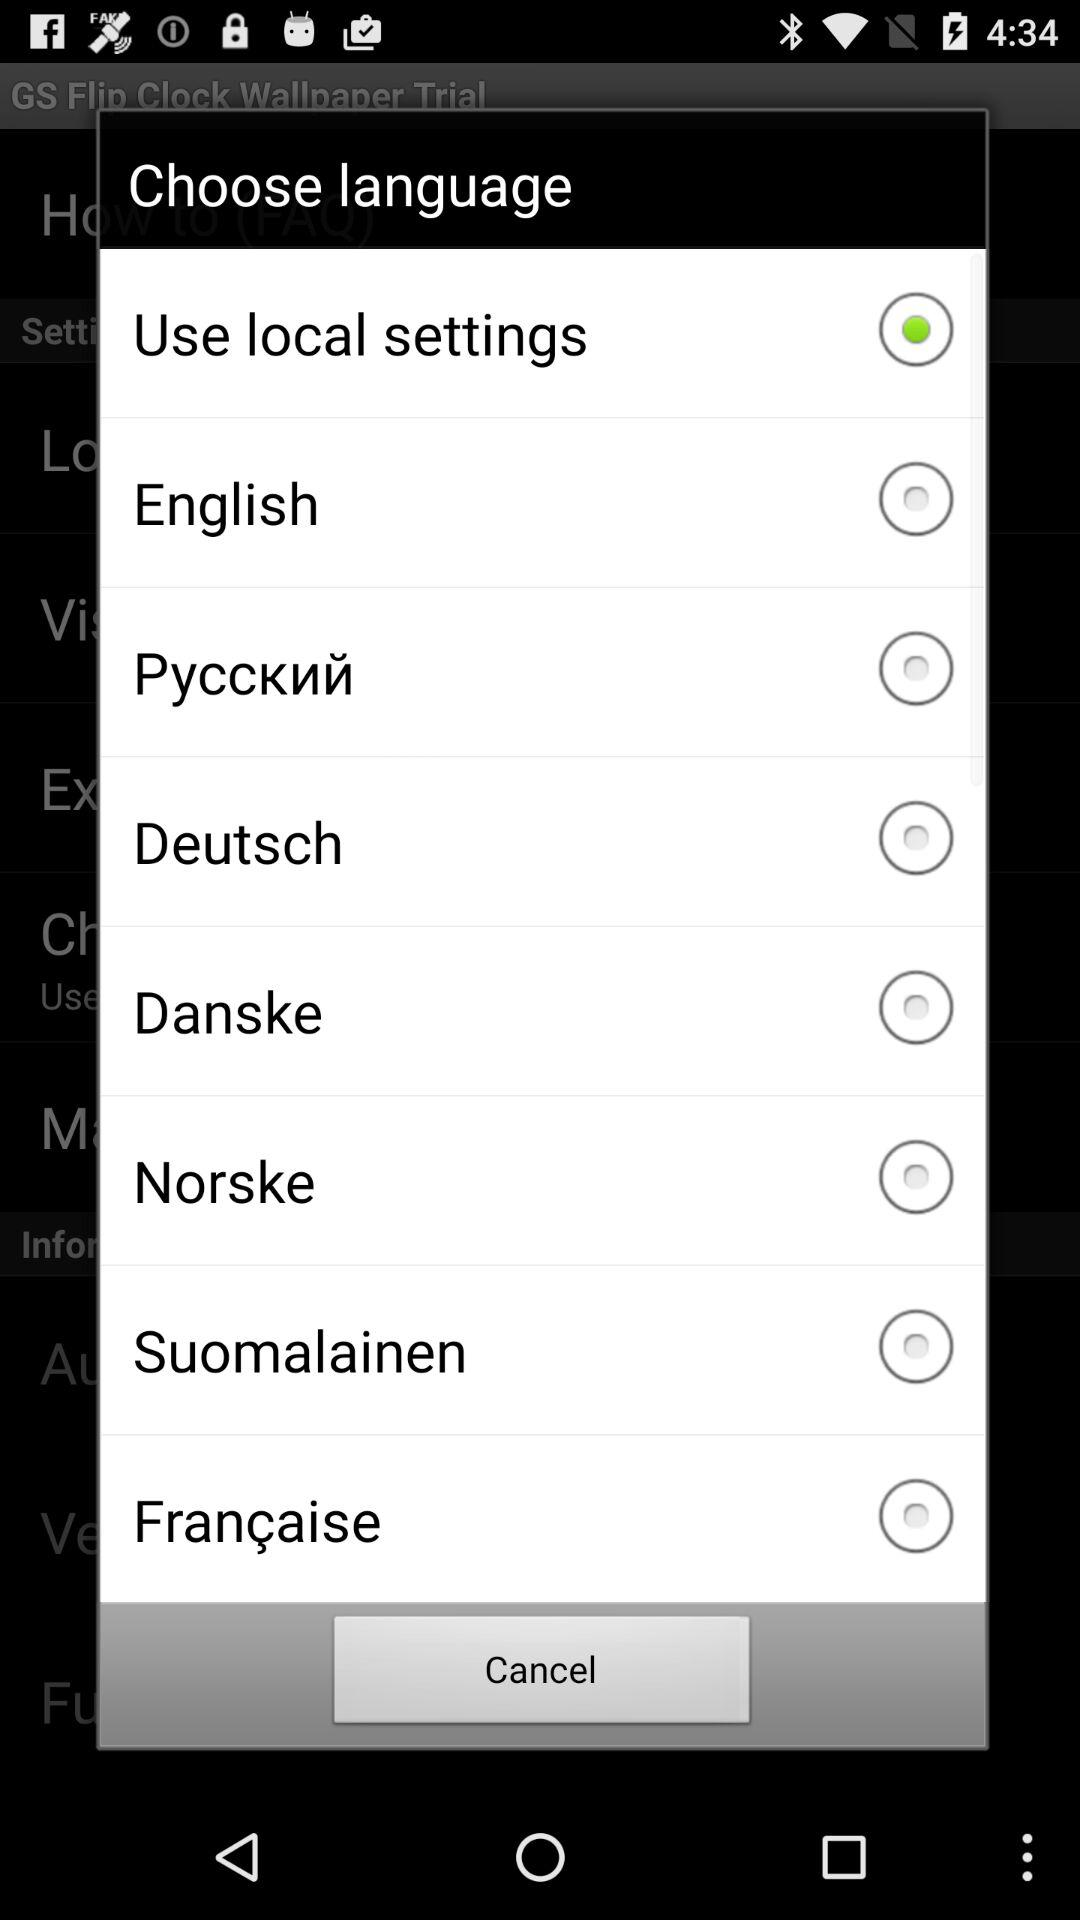Which option was selected? The selected option was "Use local settings". 